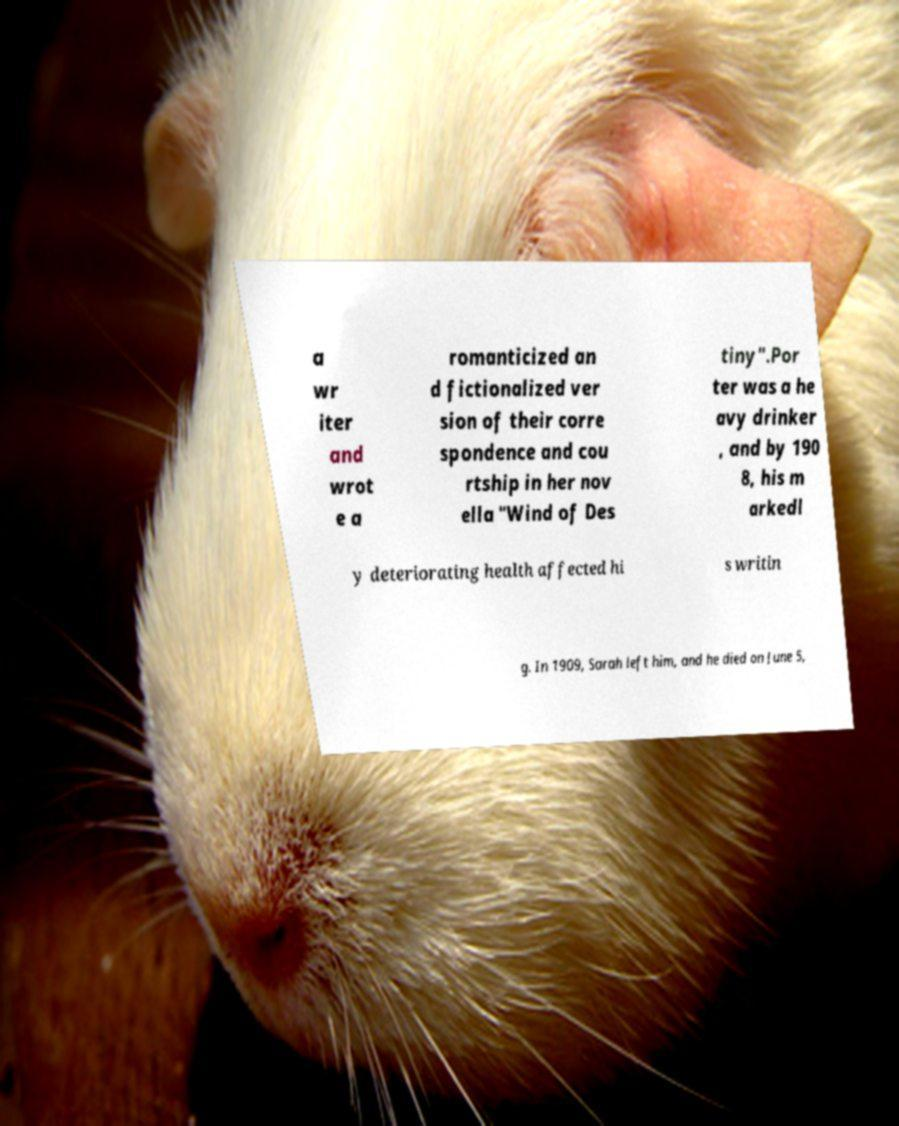There's text embedded in this image that I need extracted. Can you transcribe it verbatim? a wr iter and wrot e a romanticized an d fictionalized ver sion of their corre spondence and cou rtship in her nov ella "Wind of Des tiny".Por ter was a he avy drinker , and by 190 8, his m arkedl y deteriorating health affected hi s writin g. In 1909, Sarah left him, and he died on June 5, 